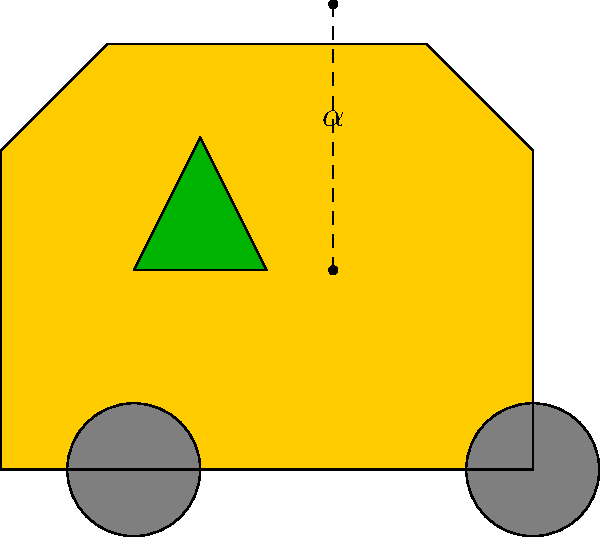In the colorful Punjabi truck art design shown above, a triangular decorative element is painted on the side of the truck. If the angle $\alpha$ formed by this triangular design is twice the complement of $60^\circ$, what is the measure of angle $\alpha$? Let's approach this step-by-step:

1) First, recall that the complement of an angle is the difference between 90° and that angle.

2) We're told that the complement of 60° is involved. Let's calculate this:
   Complement of 60° = 90° - 60° = 30°

3) Now, the question states that angle $\alpha$ is twice this complement. So we can set up the equation:
   $\alpha = 2 \times 30°$

4) Let's solve this:
   $\alpha = 2 \times 30° = 60°$

Therefore, the measure of angle $\alpha$ in the triangular design on the Punjabi truck is 60°.
Answer: $60^\circ$ 